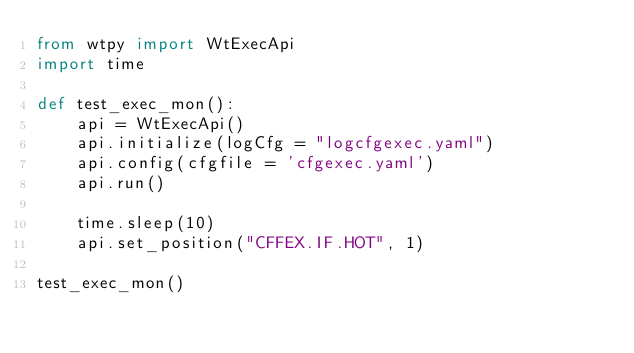<code> <loc_0><loc_0><loc_500><loc_500><_Python_>from wtpy import WtExecApi
import time

def test_exec_mon():
    api = WtExecApi()
    api.initialize(logCfg = "logcfgexec.yaml")
    api.config(cfgfile = 'cfgexec.yaml')
    api.run()

    time.sleep(10)
    api.set_position("CFFEX.IF.HOT", 1)

test_exec_mon()
</code> 